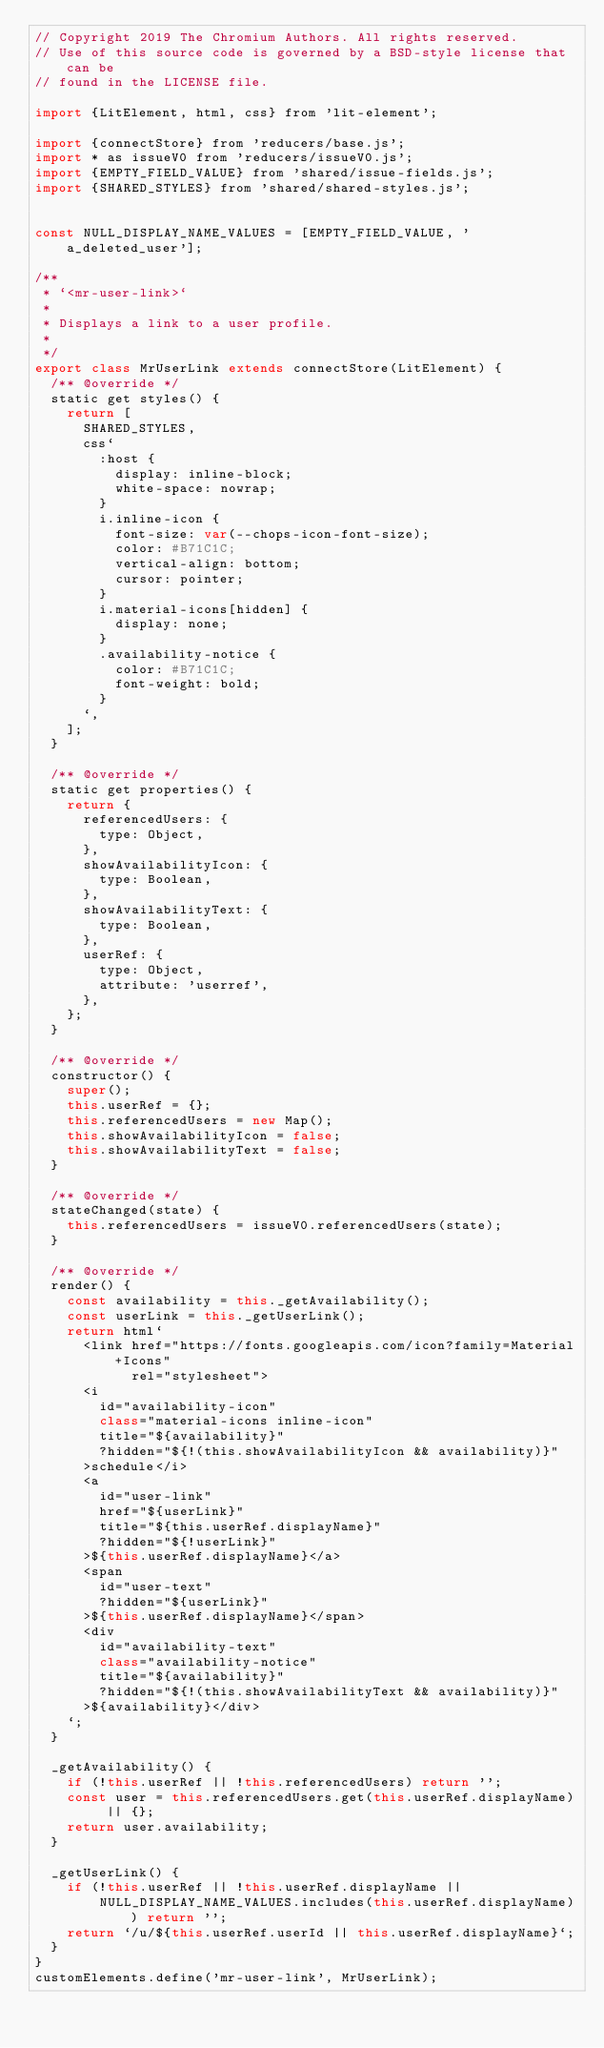Convert code to text. <code><loc_0><loc_0><loc_500><loc_500><_JavaScript_>// Copyright 2019 The Chromium Authors. All rights reserved.
// Use of this source code is governed by a BSD-style license that can be
// found in the LICENSE file.

import {LitElement, html, css} from 'lit-element';

import {connectStore} from 'reducers/base.js';
import * as issueV0 from 'reducers/issueV0.js';
import {EMPTY_FIELD_VALUE} from 'shared/issue-fields.js';
import {SHARED_STYLES} from 'shared/shared-styles.js';


const NULL_DISPLAY_NAME_VALUES = [EMPTY_FIELD_VALUE, 'a_deleted_user'];

/**
 * `<mr-user-link>`
 *
 * Displays a link to a user profile.
 *
 */
export class MrUserLink extends connectStore(LitElement) {
  /** @override */
  static get styles() {
    return [
      SHARED_STYLES,
      css`
        :host {
          display: inline-block;
          white-space: nowrap;
        }
        i.inline-icon {
          font-size: var(--chops-icon-font-size);
          color: #B71C1C;
          vertical-align: bottom;
          cursor: pointer;
        }
        i.material-icons[hidden] {
          display: none;
        }
        .availability-notice {
          color: #B71C1C;
          font-weight: bold;
        }
      `,
    ];
  }

  /** @override */
  static get properties() {
    return {
      referencedUsers: {
        type: Object,
      },
      showAvailabilityIcon: {
        type: Boolean,
      },
      showAvailabilityText: {
        type: Boolean,
      },
      userRef: {
        type: Object,
        attribute: 'userref',
      },
    };
  }

  /** @override */
  constructor() {
    super();
    this.userRef = {};
    this.referencedUsers = new Map();
    this.showAvailabilityIcon = false;
    this.showAvailabilityText = false;
  }

  /** @override */
  stateChanged(state) {
    this.referencedUsers = issueV0.referencedUsers(state);
  }

  /** @override */
  render() {
    const availability = this._getAvailability();
    const userLink = this._getUserLink();
    return html`
      <link href="https://fonts.googleapis.com/icon?family=Material+Icons"
            rel="stylesheet">
      <i
        id="availability-icon"
        class="material-icons inline-icon"
        title="${availability}"
        ?hidden="${!(this.showAvailabilityIcon && availability)}"
      >schedule</i>
      <a
        id="user-link"
        href="${userLink}"
        title="${this.userRef.displayName}"
        ?hidden="${!userLink}"
      >${this.userRef.displayName}</a>
      <span
        id="user-text"
        ?hidden="${userLink}"
      >${this.userRef.displayName}</span>
      <div
        id="availability-text"
        class="availability-notice"
        title="${availability}"
        ?hidden="${!(this.showAvailabilityText && availability)}"
      >${availability}</div>
    `;
  }

  _getAvailability() {
    if (!this.userRef || !this.referencedUsers) return '';
    const user = this.referencedUsers.get(this.userRef.displayName) || {};
    return user.availability;
  }

  _getUserLink() {
    if (!this.userRef || !this.userRef.displayName ||
        NULL_DISPLAY_NAME_VALUES.includes(this.userRef.displayName)) return '';
    return `/u/${this.userRef.userId || this.userRef.displayName}`;
  }
}
customElements.define('mr-user-link', MrUserLink);
</code> 